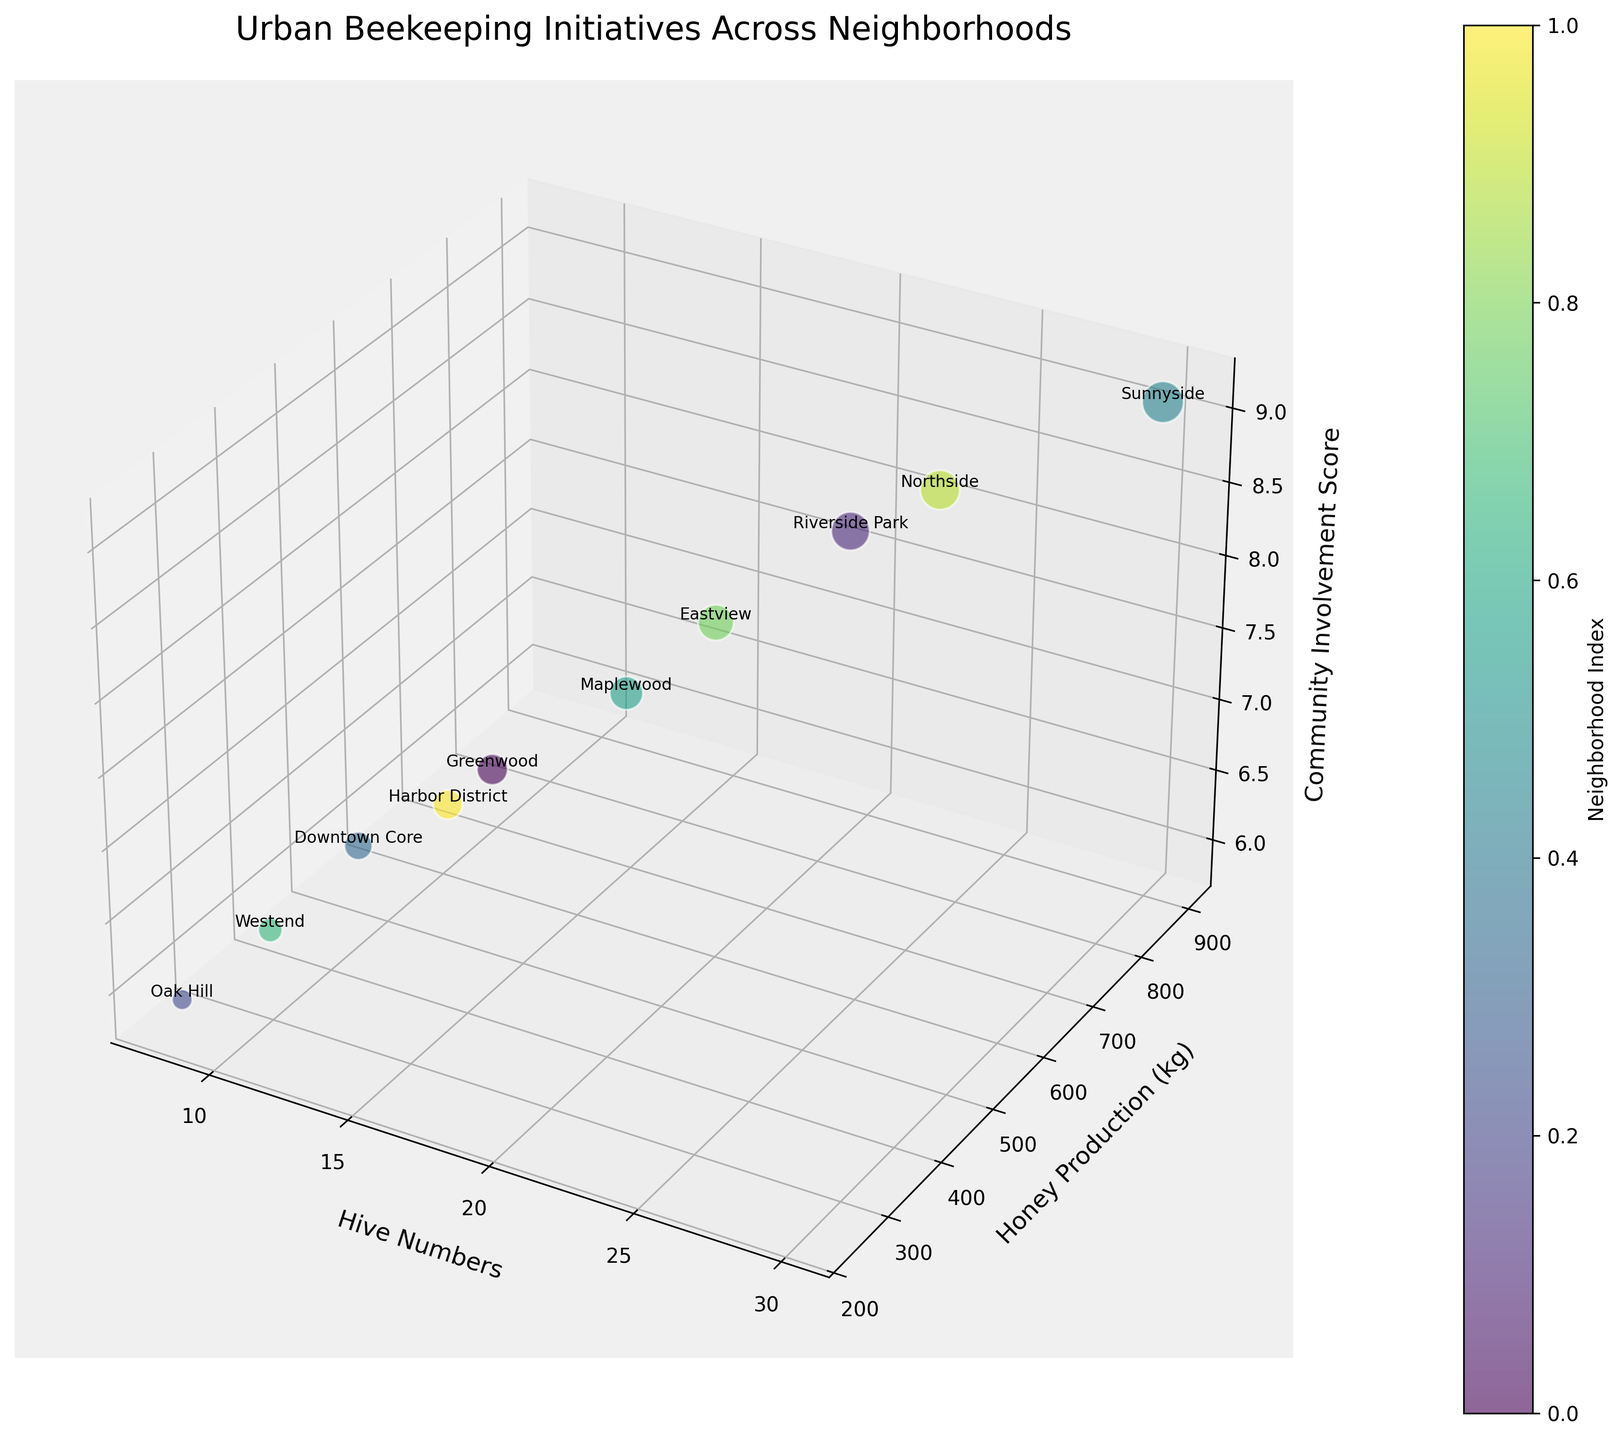What's the title of the figure? The title is usually placed at the top of the figure and provides a summary of the content.
Answer: Urban Beekeeping Initiatives Across Neighborhoods How many data points (neighborhoods) are represented in the figure? The number of data points corresponds to the number of distinct neighborhoods labeled on the plot. Count the labels or bubbles.
Answer: 10 Which neighborhood has the highest honey production? Look for the bubble positioned highest along the y-axis (Honey Production).
Answer: Sunnyside Which neighborhoods have higher community involvement scores than Eastview? Compare the z-axis values of Eastview with other bubbles to find which ones have higher z-values.
Answer: Sunnyside, Riverside Park, Northside What's the difference in hive numbers between the neighborhoods with the highest and lowest honey production? Identify the neighborhoods with the highest (Sunnyside) and lowest (Oak Hill) honey production, then subtract their hive numbers: 30 (Sunnyside) - 8 (Oak Hill).
Answer: 22 What's the sum of hive numbers in Greenwood and Downtown Core? Add the hive numbers of Greenwood and Downtown Core: 15 + 12.
Answer: 27 What is the average community involvement score across all neighborhoods? Sum the community involvement scores of all neighborhoods and divide by the number of neighborhoods (10). Calculation: (7.2 + 8.5 + 5.9 + 6.8 + 9.1 + 7.6 + 6.3 + 8.0 + 8.7 + 7.0) / 10.
Answer: 7.51 Which neighborhood has the largest bubble and what does it represent? The size of the bubble represents the community involvement score. Identify the largest bubble: 9.1 for Sunnyside.
Answer: Sunnyside Which neighborhood shows a mid-range honey production with above-average community involvement? Identify the bubble located near the middle of the y-axis range (honey production) and check if its z-axis value (community involvement) is above the average (7.51). Eastview fits this criterion with 600 kg honey production and a score of 8.0.
Answer: Eastview 